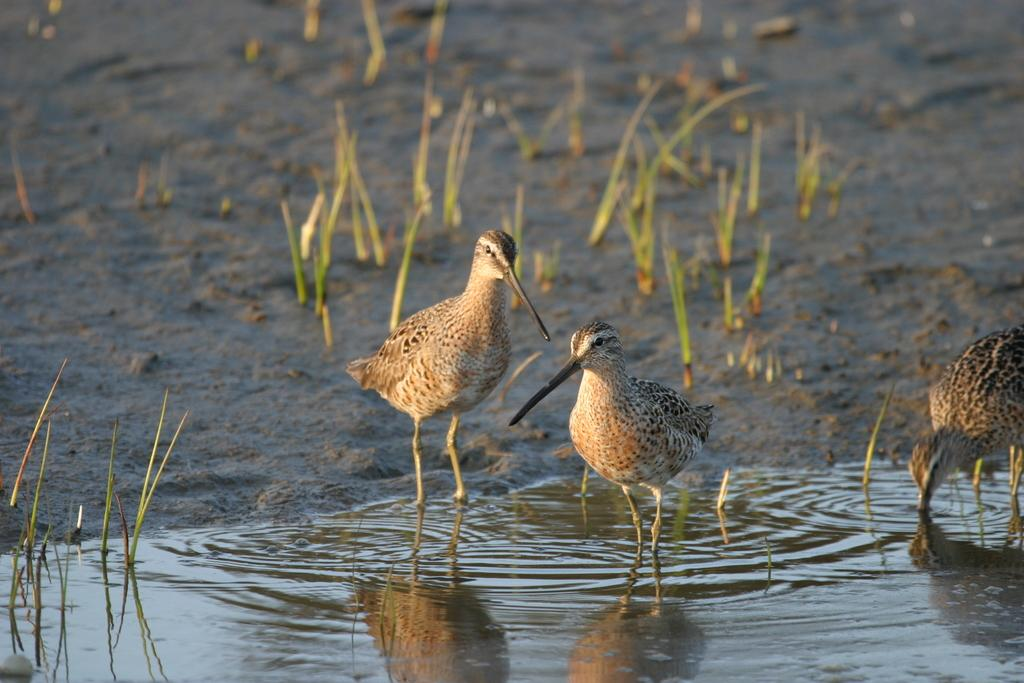What type of animals can be seen in the image? There are birds in the image. What colors are the birds? The birds have brown, black, and cream colors. What is visible in the background of the image? There is water and grass visible in the image. What type of pan can be seen in the image? There is no pan present in the image; it features birds in a natural setting with water and grass. What is the birds' response to the good-bye wave in the image? There is no good-bye wave or any indication of interaction between the birds and humans in the image. 